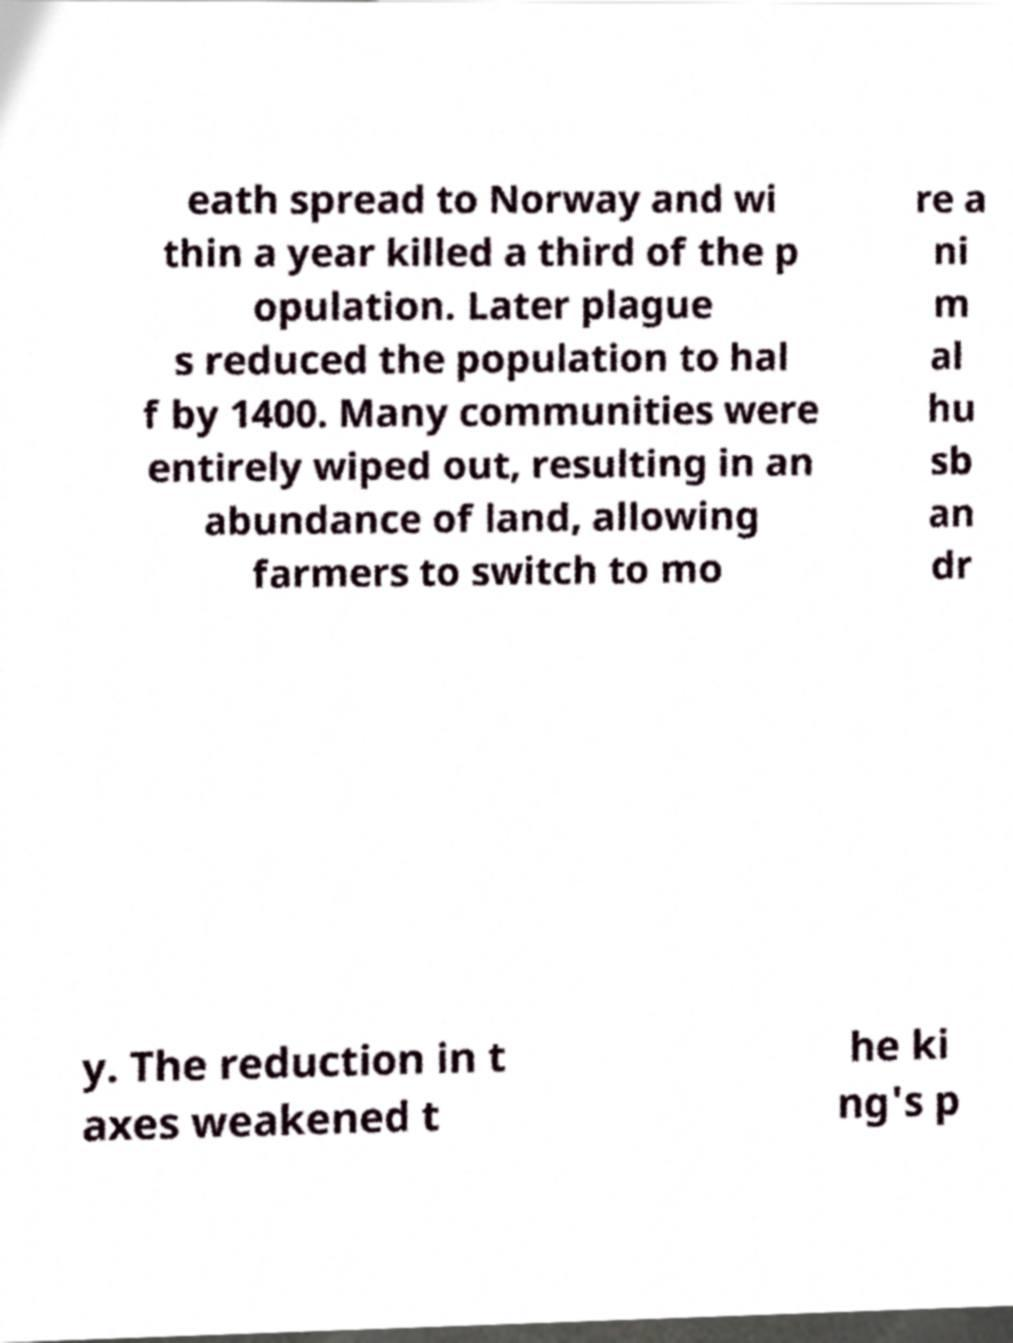I need the written content from this picture converted into text. Can you do that? eath spread to Norway and wi thin a year killed a third of the p opulation. Later plague s reduced the population to hal f by 1400. Many communities were entirely wiped out, resulting in an abundance of land, allowing farmers to switch to mo re a ni m al hu sb an dr y. The reduction in t axes weakened t he ki ng's p 